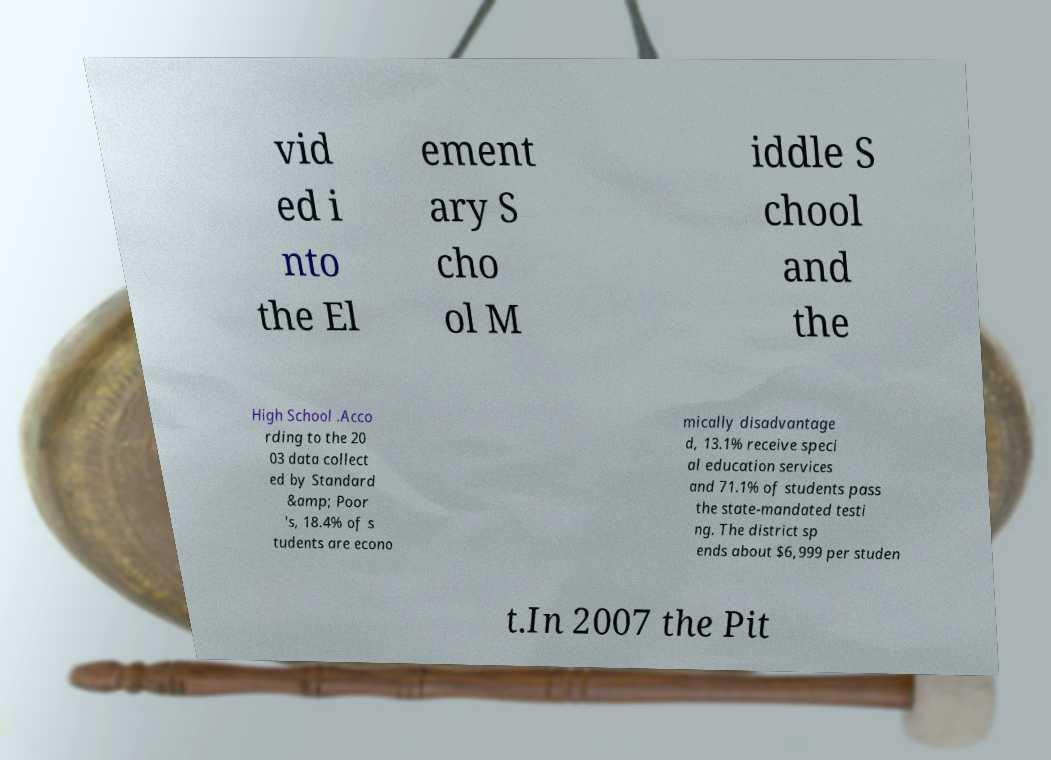Could you extract and type out the text from this image? vid ed i nto the El ement ary S cho ol M iddle S chool and the High School .Acco rding to the 20 03 data collect ed by Standard &amp; Poor 's, 18.4% of s tudents are econo mically disadvantage d, 13.1% receive speci al education services and 71.1% of students pass the state-mandated testi ng. The district sp ends about $6,999 per studen t.In 2007 the Pit 